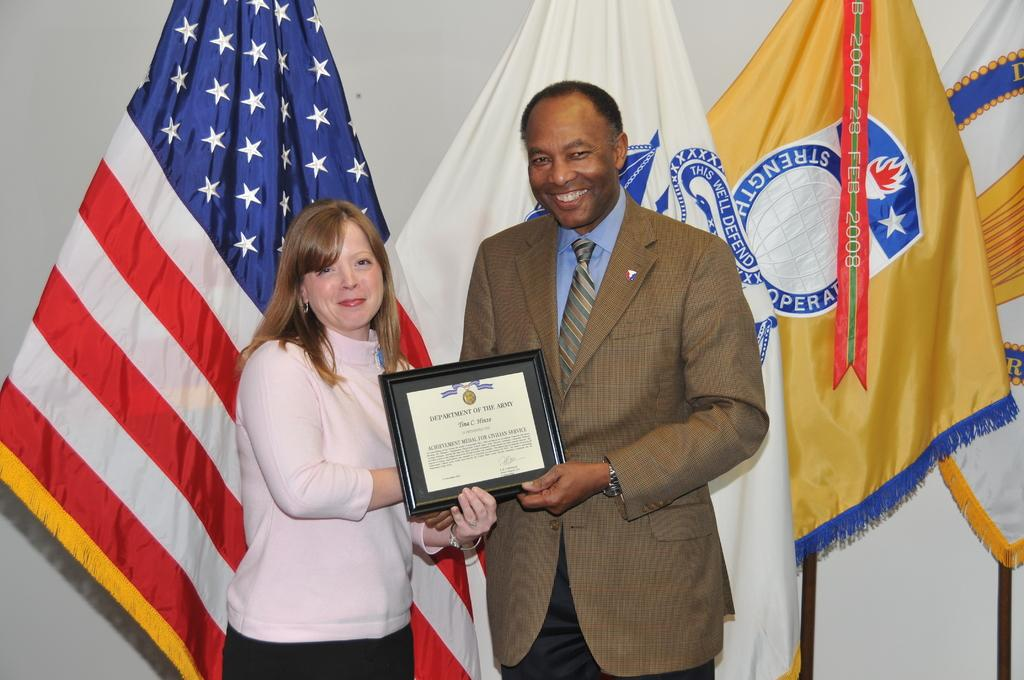What is happening in the image? There are people standing in the image. What are the people holding? The people are holding an object. Can you describe the flags in the image? There are flags in the image. What type of building can be seen in the background of the image? There is no building visible in the image. Can you tell me how many rifles are being held by the people in the image? There are no rifles present in the image; the people are holding an unspecified object. 